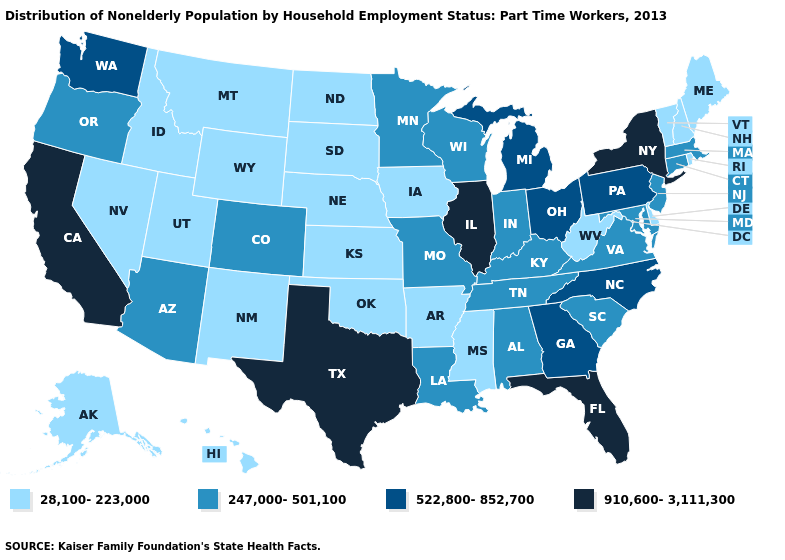What is the value of Virginia?
Write a very short answer. 247,000-501,100. Does Oregon have the highest value in the USA?
Concise answer only. No. Which states have the lowest value in the USA?
Be succinct. Alaska, Arkansas, Delaware, Hawaii, Idaho, Iowa, Kansas, Maine, Mississippi, Montana, Nebraska, Nevada, New Hampshire, New Mexico, North Dakota, Oklahoma, Rhode Island, South Dakota, Utah, Vermont, West Virginia, Wyoming. Does the map have missing data?
Give a very brief answer. No. What is the value of Montana?
Give a very brief answer. 28,100-223,000. Name the states that have a value in the range 28,100-223,000?
Keep it brief. Alaska, Arkansas, Delaware, Hawaii, Idaho, Iowa, Kansas, Maine, Mississippi, Montana, Nebraska, Nevada, New Hampshire, New Mexico, North Dakota, Oklahoma, Rhode Island, South Dakota, Utah, Vermont, West Virginia, Wyoming. Name the states that have a value in the range 28,100-223,000?
Write a very short answer. Alaska, Arkansas, Delaware, Hawaii, Idaho, Iowa, Kansas, Maine, Mississippi, Montana, Nebraska, Nevada, New Hampshire, New Mexico, North Dakota, Oklahoma, Rhode Island, South Dakota, Utah, Vermont, West Virginia, Wyoming. What is the value of New York?
Short answer required. 910,600-3,111,300. Name the states that have a value in the range 247,000-501,100?
Keep it brief. Alabama, Arizona, Colorado, Connecticut, Indiana, Kentucky, Louisiana, Maryland, Massachusetts, Minnesota, Missouri, New Jersey, Oregon, South Carolina, Tennessee, Virginia, Wisconsin. Does Connecticut have the same value as Arkansas?
Short answer required. No. Does New Hampshire have the same value as Wisconsin?
Quick response, please. No. Name the states that have a value in the range 28,100-223,000?
Keep it brief. Alaska, Arkansas, Delaware, Hawaii, Idaho, Iowa, Kansas, Maine, Mississippi, Montana, Nebraska, Nevada, New Hampshire, New Mexico, North Dakota, Oklahoma, Rhode Island, South Dakota, Utah, Vermont, West Virginia, Wyoming. Does Washington have a higher value than Illinois?
Concise answer only. No. What is the value of North Carolina?
Give a very brief answer. 522,800-852,700. Name the states that have a value in the range 28,100-223,000?
Concise answer only. Alaska, Arkansas, Delaware, Hawaii, Idaho, Iowa, Kansas, Maine, Mississippi, Montana, Nebraska, Nevada, New Hampshire, New Mexico, North Dakota, Oklahoma, Rhode Island, South Dakota, Utah, Vermont, West Virginia, Wyoming. 